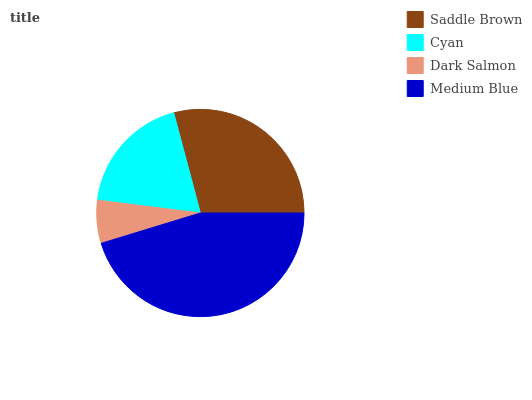Is Dark Salmon the minimum?
Answer yes or no. Yes. Is Medium Blue the maximum?
Answer yes or no. Yes. Is Cyan the minimum?
Answer yes or no. No. Is Cyan the maximum?
Answer yes or no. No. Is Saddle Brown greater than Cyan?
Answer yes or no. Yes. Is Cyan less than Saddle Brown?
Answer yes or no. Yes. Is Cyan greater than Saddle Brown?
Answer yes or no. No. Is Saddle Brown less than Cyan?
Answer yes or no. No. Is Saddle Brown the high median?
Answer yes or no. Yes. Is Cyan the low median?
Answer yes or no. Yes. Is Dark Salmon the high median?
Answer yes or no. No. Is Dark Salmon the low median?
Answer yes or no. No. 